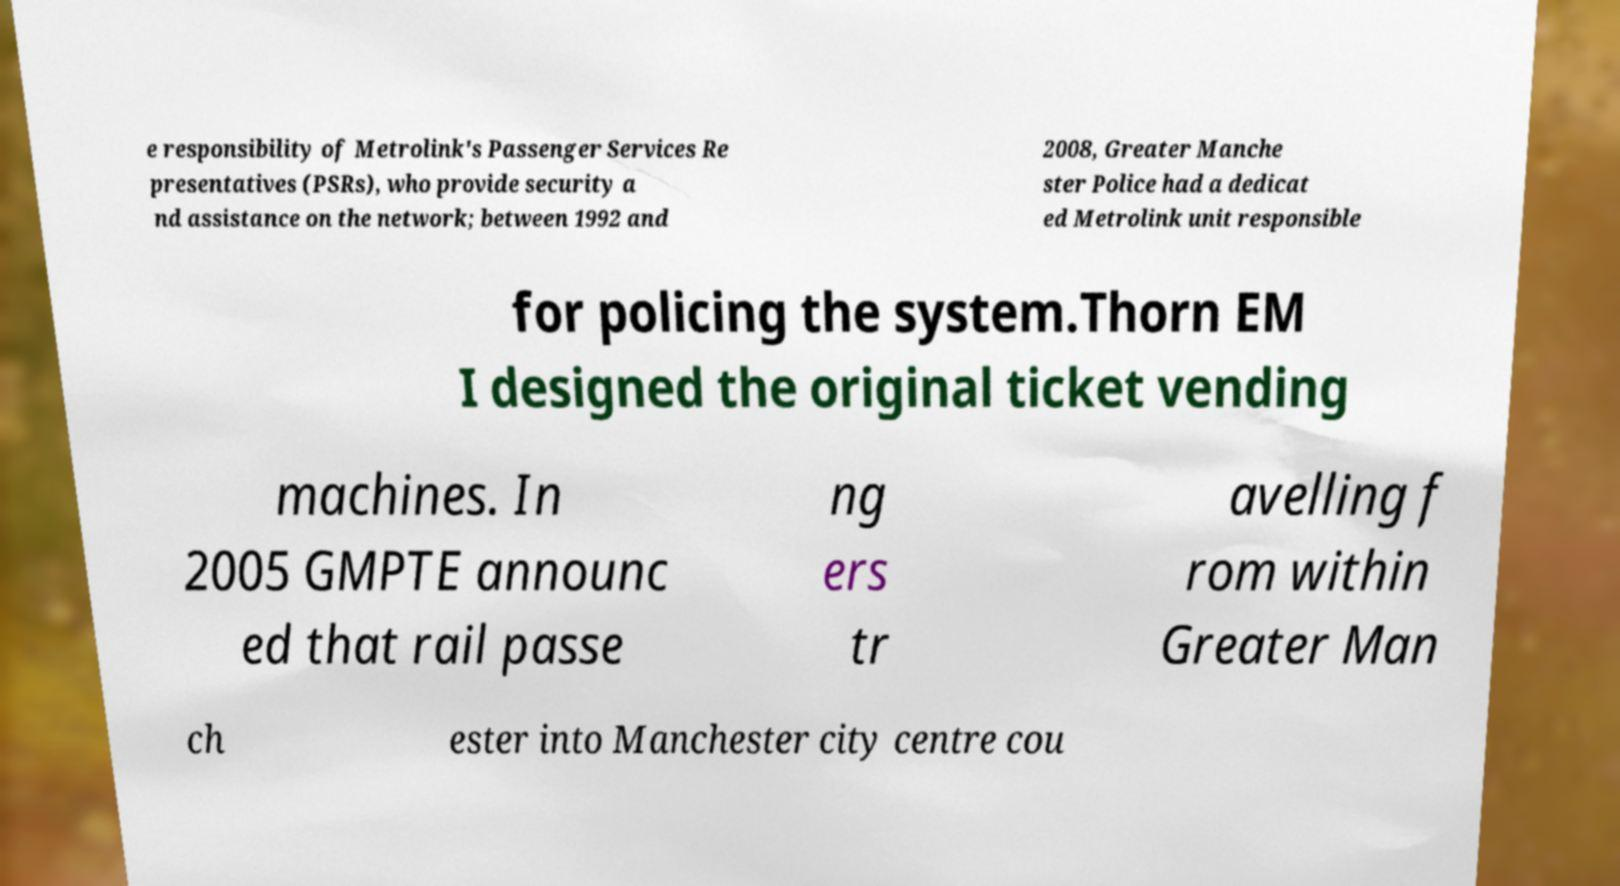Could you extract and type out the text from this image? e responsibility of Metrolink's Passenger Services Re presentatives (PSRs), who provide security a nd assistance on the network; between 1992 and 2008, Greater Manche ster Police had a dedicat ed Metrolink unit responsible for policing the system.Thorn EM I designed the original ticket vending machines. In 2005 GMPTE announc ed that rail passe ng ers tr avelling f rom within Greater Man ch ester into Manchester city centre cou 